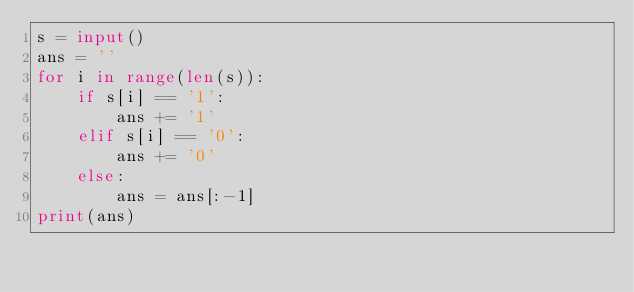Convert code to text. <code><loc_0><loc_0><loc_500><loc_500><_Python_>s = input()
ans = ''
for i in range(len(s)):
    if s[i] == '1':
        ans += '1'
    elif s[i] == '0':
        ans += '0'
    else:
        ans = ans[:-1]
print(ans)</code> 